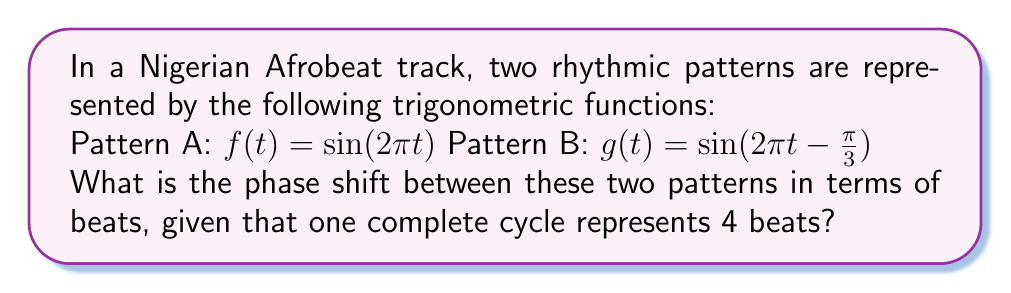Help me with this question. To find the phase shift between the two rhythmic patterns, we need to follow these steps:

1) First, let's identify the general form of a sine function:
   $y = A \sin(B(x - C)) + D$
   Where C represents the phase shift.

2) In our case:
   Pattern A: $f(t) = \sin(2\pi t)$
   Pattern B: $g(t) = \sin(2\pi t - \frac{\pi}{3})$

3) Comparing Pattern B to the general form, we can see that the phase shift C is $\frac{\pi}{6}$. This is because:
   $\sin(2\pi t - \frac{\pi}{3}) = \sin(2\pi(t - \frac{1}{6}))$

4) Now, we know that the phase shift in radians is $\frac{\pi}{6}$.

5) To convert this to beats, we need to consider that one complete cycle (2π radians) represents 4 beats.

6) We can set up the following proportion:
   $\frac{2\pi \text{ radians}}{4 \text{ beats}} = \frac{\frac{\pi}{6} \text{ radians}}{x \text{ beats}}$

7) Cross multiply:
   $2\pi x = 4 \cdot \frac{\pi}{6}$

8) Solve for x:
   $x = \frac{4 \cdot \frac{\pi}{6}}{2\pi} = \frac{1}{3}$

Therefore, the phase shift is $\frac{1}{3}$ of a beat.
Answer: $\frac{1}{3}$ beat 